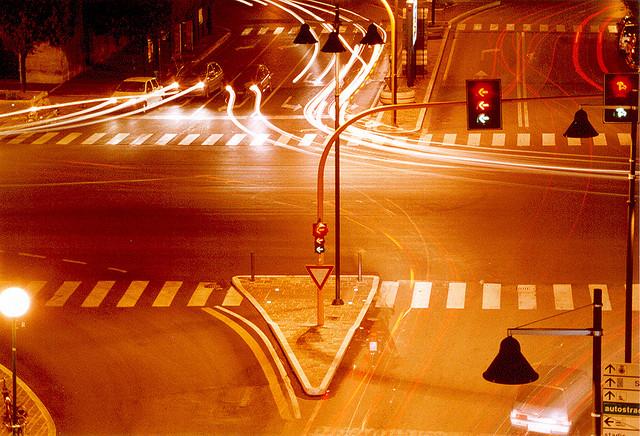Why are the streets so empty?
Keep it brief. Night. How many cars can be viewed in this picture?
Keep it brief. 4. What time of day is this scene taking place?
Give a very brief answer. Night. 